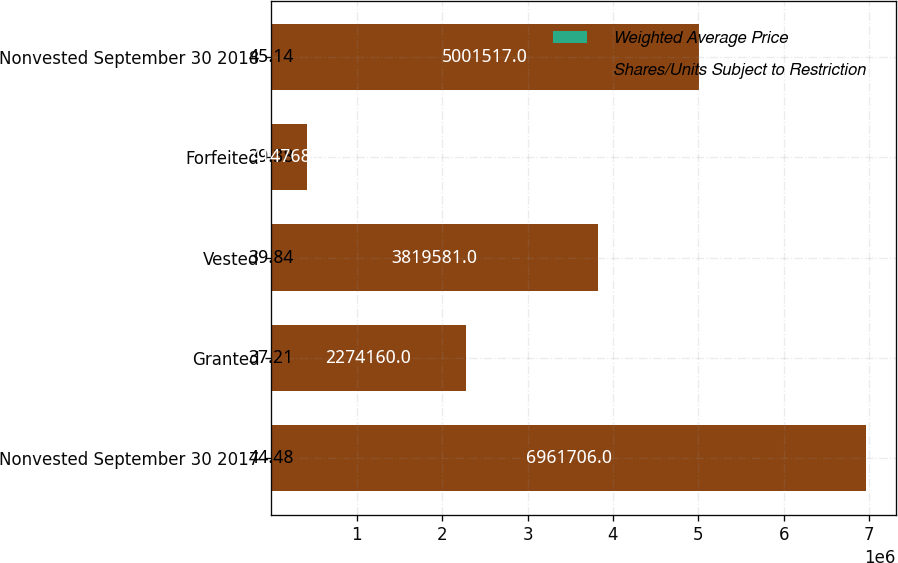Convert chart to OTSL. <chart><loc_0><loc_0><loc_500><loc_500><stacked_bar_chart><ecel><fcel>Nonvested September 30 2017<fcel>Granted<fcel>Vested<fcel>Forfeited<fcel>Nonvested September 30 2018<nl><fcel>Weighted Average Price<fcel>44.48<fcel>37.21<fcel>39.84<fcel>39.38<fcel>45.14<nl><fcel>Shares/Units Subject to Restriction<fcel>6.96171e+06<fcel>2.27416e+06<fcel>3.81958e+06<fcel>414768<fcel>5.00152e+06<nl></chart> 